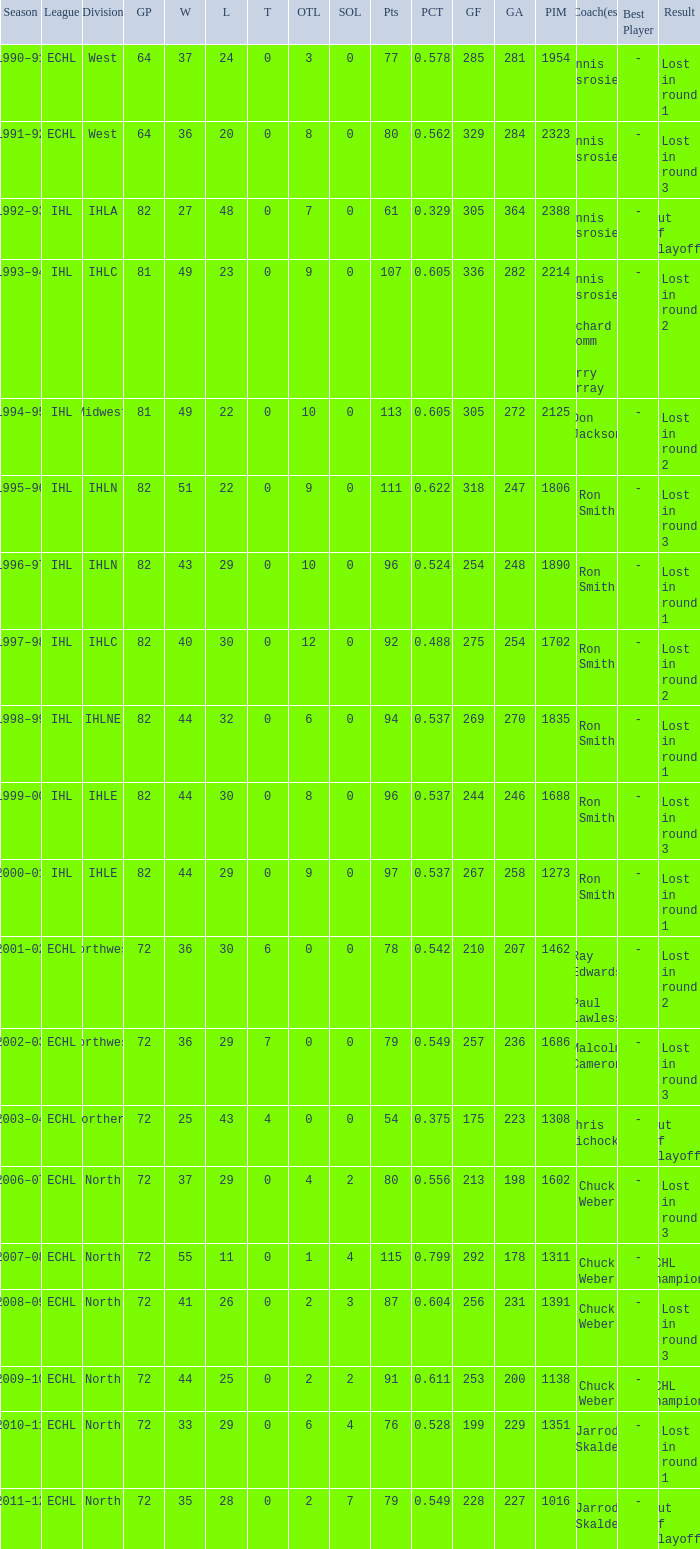What was the highest SOL where the team lost in round 3? 3.0. 